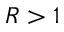Convert formula to latex. <formula><loc_0><loc_0><loc_500><loc_500>R > 1</formula> 